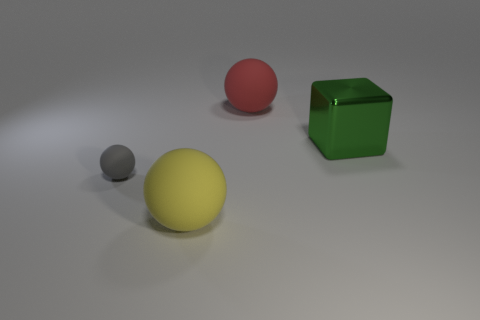What number of small things are green blocks or gray matte balls?
Keep it short and to the point. 1. Are there more tiny red rubber things than large yellow things?
Make the answer very short. No. Are the yellow sphere and the tiny gray ball made of the same material?
Your response must be concise. Yes. Is there any other thing that has the same material as the large green object?
Your answer should be very brief. No. Is the number of big things that are behind the cube greater than the number of gray rubber blocks?
Provide a short and direct response. Yes. How many other red matte objects are the same shape as the small thing?
Make the answer very short. 1. What size is the red object that is the same material as the large yellow object?
Ensure brevity in your answer.  Large. There is a thing that is both behind the tiny sphere and in front of the large red rubber object; what color is it?
Your response must be concise. Green. How many gray matte spheres have the same size as the red matte sphere?
Your answer should be very brief. 0. What size is the rubber sphere that is behind the yellow rubber sphere and in front of the large cube?
Provide a short and direct response. Small. 